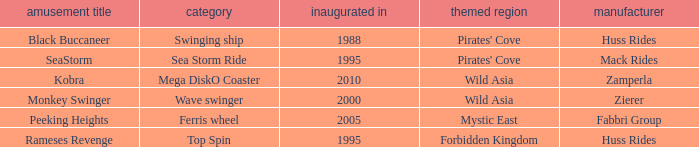What ride was manufactured by Zierer? Monkey Swinger. 